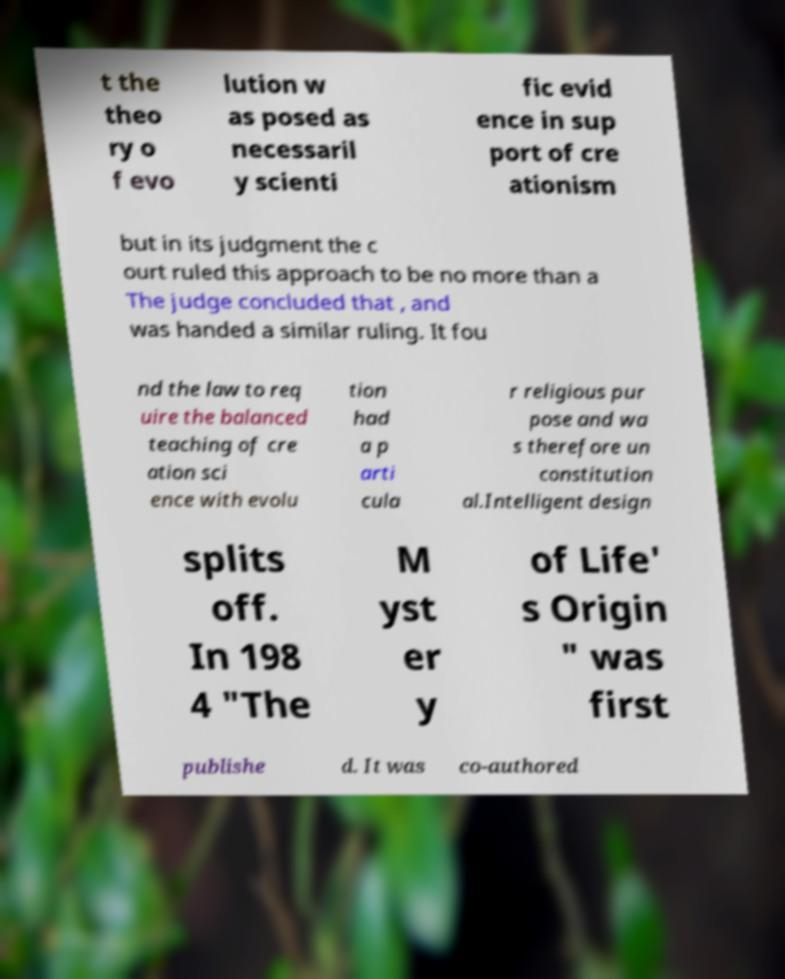Could you assist in decoding the text presented in this image and type it out clearly? t the theo ry o f evo lution w as posed as necessaril y scienti fic evid ence in sup port of cre ationism but in its judgment the c ourt ruled this approach to be no more than a The judge concluded that , and was handed a similar ruling. It fou nd the law to req uire the balanced teaching of cre ation sci ence with evolu tion had a p arti cula r religious pur pose and wa s therefore un constitution al.Intelligent design splits off. In 198 4 "The M yst er y of Life' s Origin " was first publishe d. It was co-authored 